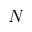<formula> <loc_0><loc_0><loc_500><loc_500>N</formula> 